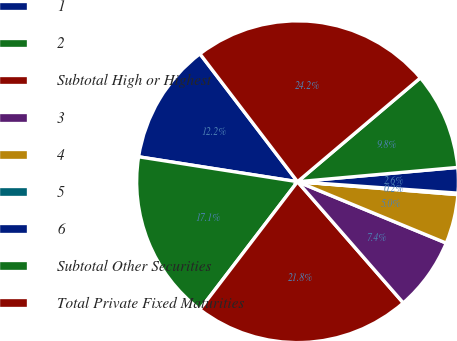<chart> <loc_0><loc_0><loc_500><loc_500><pie_chart><fcel>1<fcel>2<fcel>Subtotal High or Highest<fcel>3<fcel>4<fcel>5<fcel>6<fcel>Subtotal Other Securities<fcel>Total Private Fixed Maturities<nl><fcel>12.15%<fcel>17.09%<fcel>21.8%<fcel>7.35%<fcel>4.95%<fcel>0.15%<fcel>2.55%<fcel>9.75%<fcel>24.2%<nl></chart> 